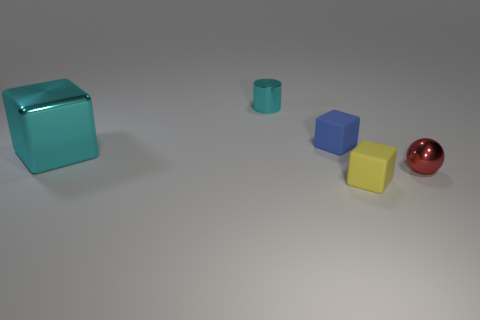Subtract all small blue matte blocks. How many blocks are left? 2 Subtract all yellow cubes. How many cubes are left? 2 Subtract all cyan cylinders. How many yellow cubes are left? 1 Subtract all cylinders. How many objects are left? 4 Subtract all purple cubes. Subtract all cyan cylinders. How many cubes are left? 3 Subtract all shiny cylinders. Subtract all tiny rubber things. How many objects are left? 2 Add 1 red metal balls. How many red metal balls are left? 2 Add 1 cyan cylinders. How many cyan cylinders exist? 2 Add 3 big brown metal things. How many objects exist? 8 Subtract 0 yellow spheres. How many objects are left? 5 